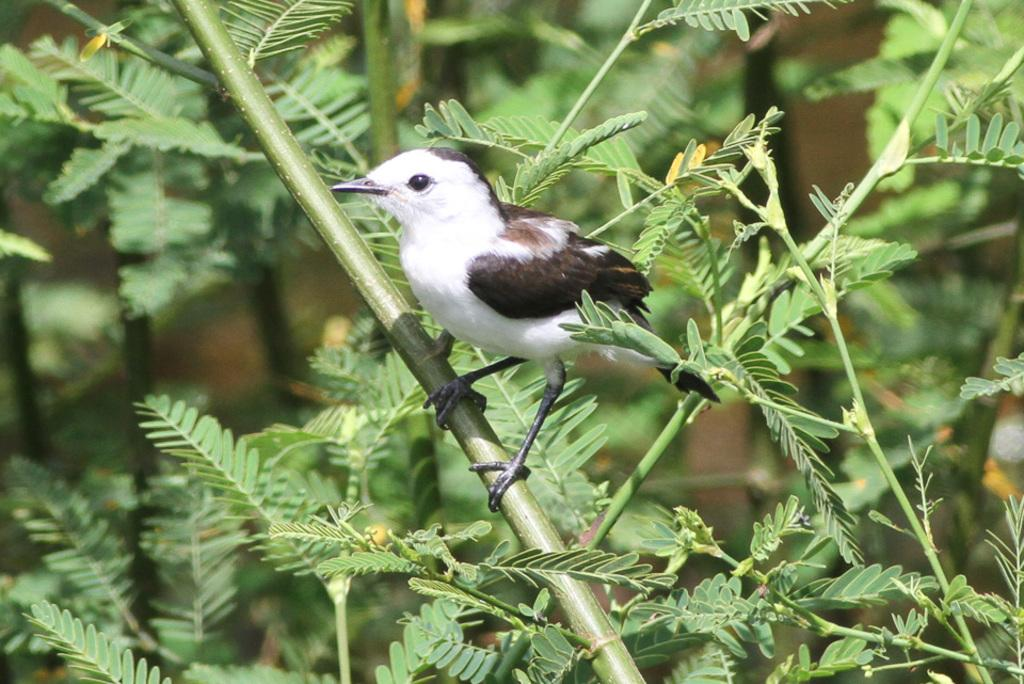What type of animal is in the image? There is a bird in the image. Where is the bird located? The bird is on a stem in the image. What else can be seen in the image besides the bird? There are leaves in the image. What color is the background of the image? The background of the image is green. What type of hat is the bird wearing in the image? There is no hat present in the image; the bird is on a stem with leaves. 